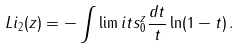<formula> <loc_0><loc_0><loc_500><loc_500>L i _ { 2 } ( z ) = - \int \lim i t s ^ { z } _ { 0 } \frac { d t } { t } \ln ( 1 - t ) \, .</formula> 